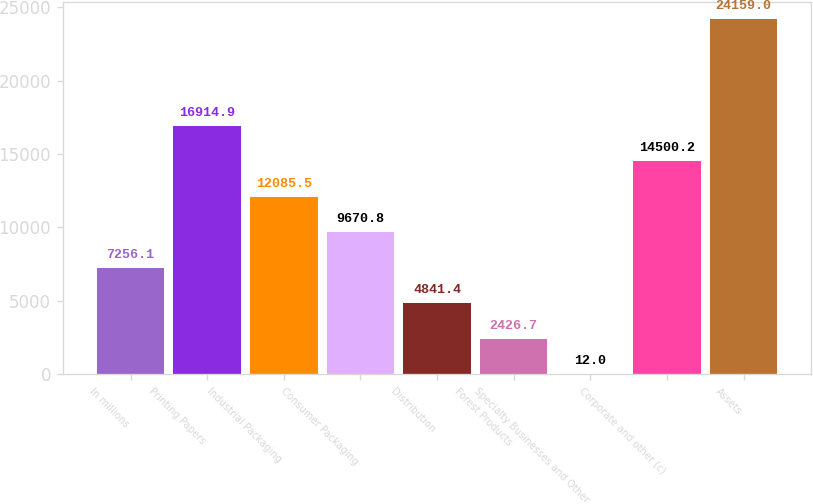Convert chart to OTSL. <chart><loc_0><loc_0><loc_500><loc_500><bar_chart><fcel>In millions<fcel>Printing Papers<fcel>Industrial Packaging<fcel>Consumer Packaging<fcel>Distribution<fcel>Forest Products<fcel>Specialty Businesses and Other<fcel>Corporate and other (c)<fcel>Assets<nl><fcel>7256.1<fcel>16914.9<fcel>12085.5<fcel>9670.8<fcel>4841.4<fcel>2426.7<fcel>12<fcel>14500.2<fcel>24159<nl></chart> 